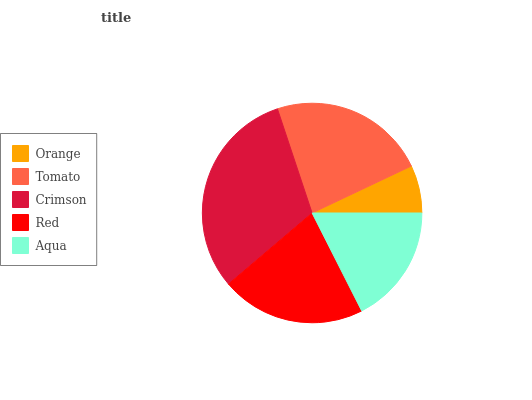Is Orange the minimum?
Answer yes or no. Yes. Is Crimson the maximum?
Answer yes or no. Yes. Is Tomato the minimum?
Answer yes or no. No. Is Tomato the maximum?
Answer yes or no. No. Is Tomato greater than Orange?
Answer yes or no. Yes. Is Orange less than Tomato?
Answer yes or no. Yes. Is Orange greater than Tomato?
Answer yes or no. No. Is Tomato less than Orange?
Answer yes or no. No. Is Red the high median?
Answer yes or no. Yes. Is Red the low median?
Answer yes or no. Yes. Is Tomato the high median?
Answer yes or no. No. Is Tomato the low median?
Answer yes or no. No. 